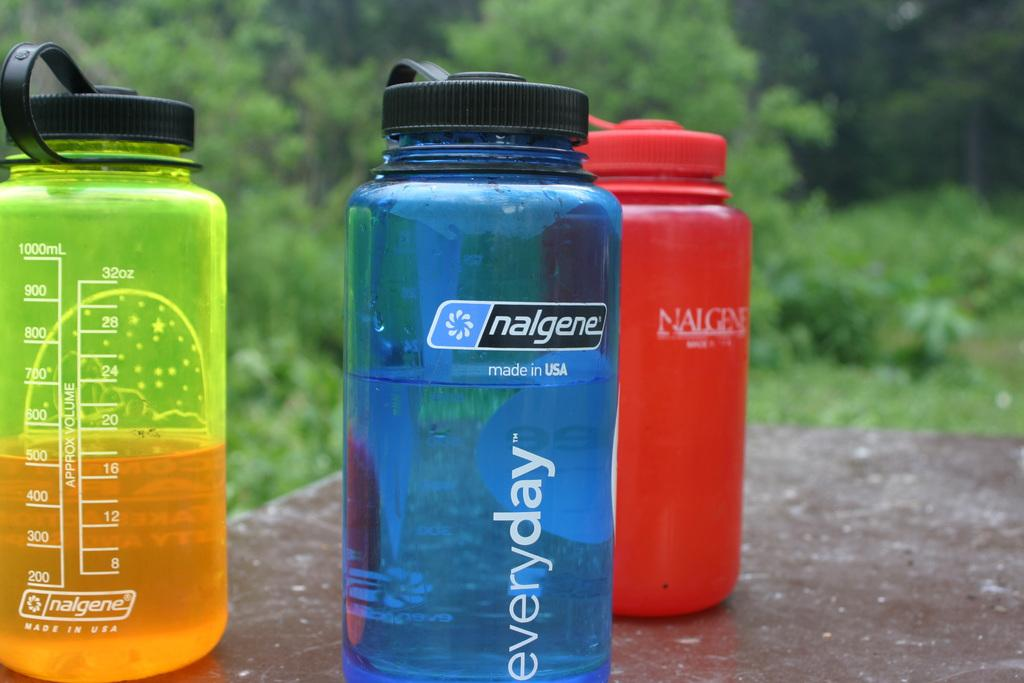How many different colors of bottles can be seen in the image? There are three colors of bottles in the image. What are the colors of the bottles? The colors of the bottles are green, blue, and red. Where are the bottles located in the image? The bottles are placed on the floor. What can be seen in the background of the image? There are trees visible in the background of the image. What type of potato is being harvested by the sister in the image? There is no sister or potato present in the image; it features bottles on the floor with trees in the background. 